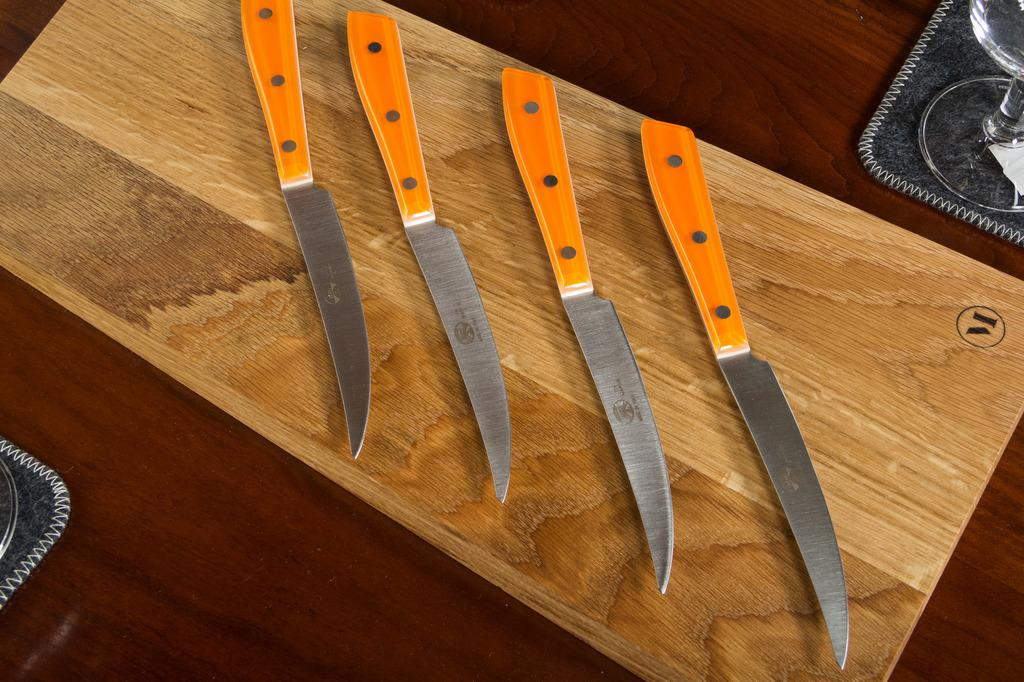What type of surface is visible in the image? There is a wooden surface in the image. What objects are placed on the wooden surface? There are knives on the wooden surface. What type of container is present in the image? There is a glass in the image. Can you describe the object in the top right corner of the image? There is an object in the top right corner of the image, but its specific details are not clear from the provided facts. Can you describe the object on the left side of the image? There is an object on the left side of the image, but its specific details are not clear from the provided facts. What type of advertisement can be seen on the ship in the image? There is no ship present in the image, and therefore no advertisement can be seen on it. 